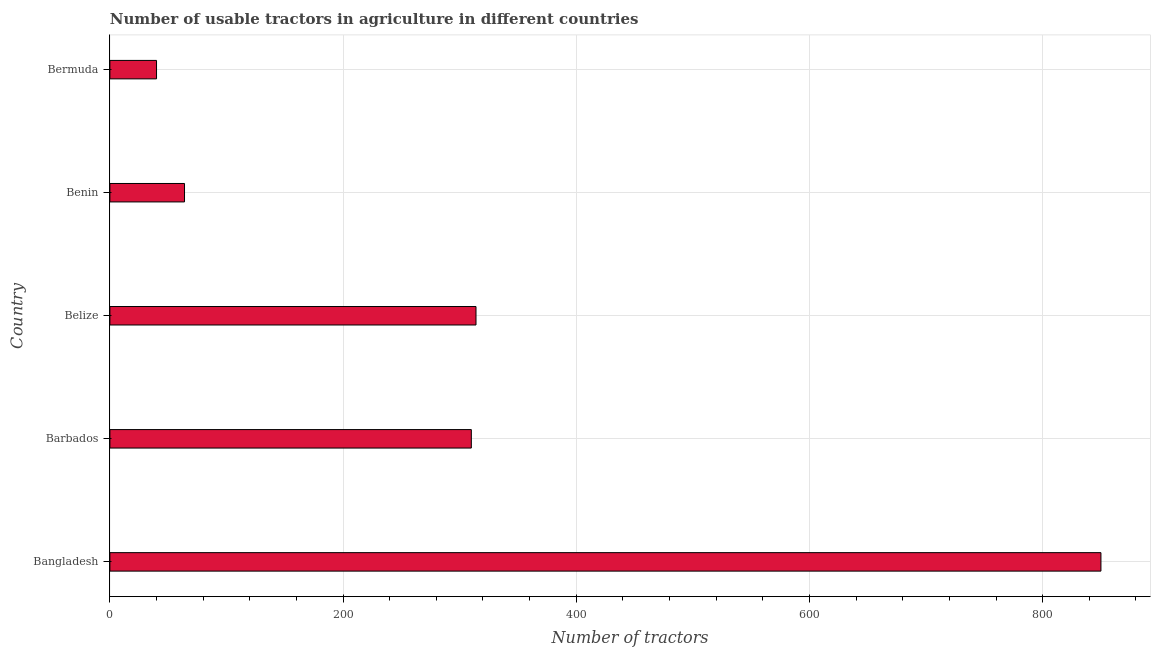Does the graph contain any zero values?
Your response must be concise. No. Does the graph contain grids?
Offer a very short reply. Yes. What is the title of the graph?
Your answer should be compact. Number of usable tractors in agriculture in different countries. What is the label or title of the X-axis?
Your response must be concise. Number of tractors. What is the number of tractors in Barbados?
Ensure brevity in your answer.  310. Across all countries, what is the maximum number of tractors?
Provide a succinct answer. 850. Across all countries, what is the minimum number of tractors?
Your answer should be compact. 40. In which country was the number of tractors minimum?
Offer a terse response. Bermuda. What is the sum of the number of tractors?
Give a very brief answer. 1578. What is the difference between the number of tractors in Bangladesh and Belize?
Provide a succinct answer. 536. What is the average number of tractors per country?
Offer a terse response. 315. What is the median number of tractors?
Your answer should be compact. 310. What is the ratio of the number of tractors in Bangladesh to that in Belize?
Keep it short and to the point. 2.71. Is the number of tractors in Bangladesh less than that in Belize?
Ensure brevity in your answer.  No. Is the difference between the number of tractors in Bangladesh and Bermuda greater than the difference between any two countries?
Offer a terse response. Yes. What is the difference between the highest and the second highest number of tractors?
Ensure brevity in your answer.  536. What is the difference between the highest and the lowest number of tractors?
Your answer should be compact. 810. In how many countries, is the number of tractors greater than the average number of tractors taken over all countries?
Your answer should be very brief. 1. How many bars are there?
Offer a terse response. 5. Are all the bars in the graph horizontal?
Your answer should be compact. Yes. How many countries are there in the graph?
Your response must be concise. 5. What is the difference between two consecutive major ticks on the X-axis?
Provide a succinct answer. 200. What is the Number of tractors of Bangladesh?
Offer a terse response. 850. What is the Number of tractors of Barbados?
Make the answer very short. 310. What is the Number of tractors of Belize?
Give a very brief answer. 314. What is the difference between the Number of tractors in Bangladesh and Barbados?
Your answer should be very brief. 540. What is the difference between the Number of tractors in Bangladesh and Belize?
Offer a terse response. 536. What is the difference between the Number of tractors in Bangladesh and Benin?
Your response must be concise. 786. What is the difference between the Number of tractors in Bangladesh and Bermuda?
Offer a very short reply. 810. What is the difference between the Number of tractors in Barbados and Belize?
Ensure brevity in your answer.  -4. What is the difference between the Number of tractors in Barbados and Benin?
Offer a very short reply. 246. What is the difference between the Number of tractors in Barbados and Bermuda?
Your answer should be very brief. 270. What is the difference between the Number of tractors in Belize and Benin?
Make the answer very short. 250. What is the difference between the Number of tractors in Belize and Bermuda?
Your answer should be very brief. 274. What is the difference between the Number of tractors in Benin and Bermuda?
Your answer should be very brief. 24. What is the ratio of the Number of tractors in Bangladesh to that in Barbados?
Your response must be concise. 2.74. What is the ratio of the Number of tractors in Bangladesh to that in Belize?
Keep it short and to the point. 2.71. What is the ratio of the Number of tractors in Bangladesh to that in Benin?
Keep it short and to the point. 13.28. What is the ratio of the Number of tractors in Bangladesh to that in Bermuda?
Your answer should be very brief. 21.25. What is the ratio of the Number of tractors in Barbados to that in Belize?
Provide a short and direct response. 0.99. What is the ratio of the Number of tractors in Barbados to that in Benin?
Your answer should be very brief. 4.84. What is the ratio of the Number of tractors in Barbados to that in Bermuda?
Your answer should be very brief. 7.75. What is the ratio of the Number of tractors in Belize to that in Benin?
Your answer should be very brief. 4.91. What is the ratio of the Number of tractors in Belize to that in Bermuda?
Ensure brevity in your answer.  7.85. 